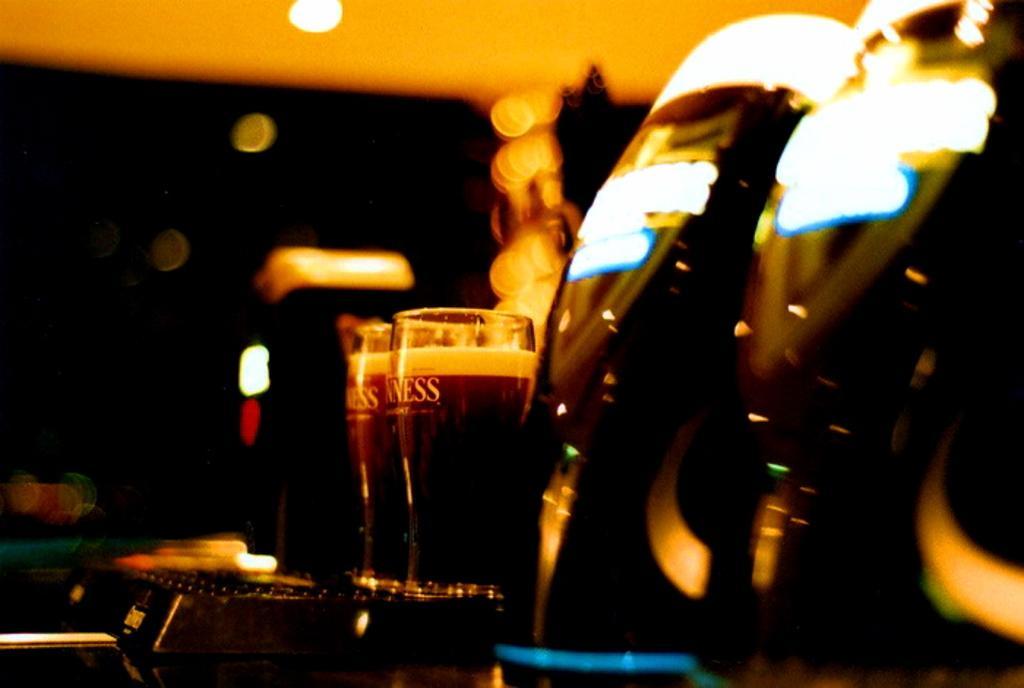Can you describe this image briefly? This image consists of drinks in two glasses. It is kept on the table. The background is blurred. At the top, we can see a light. On the right, we can see the black color objects. 